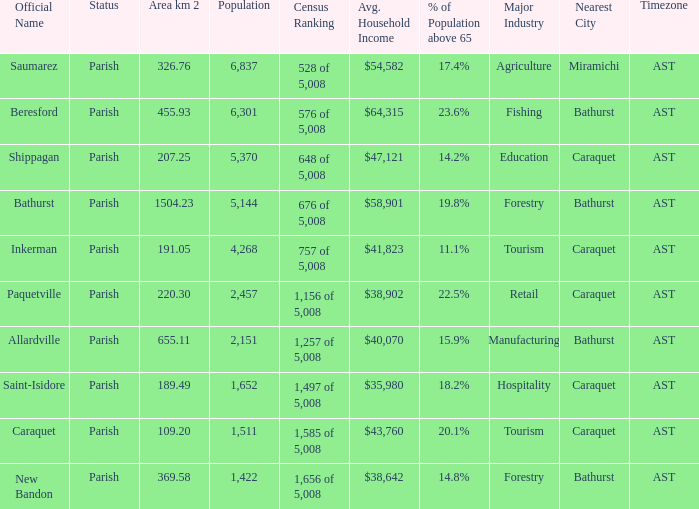What is the Area of the Allardville Parish with a Population smaller than 2,151? None. 